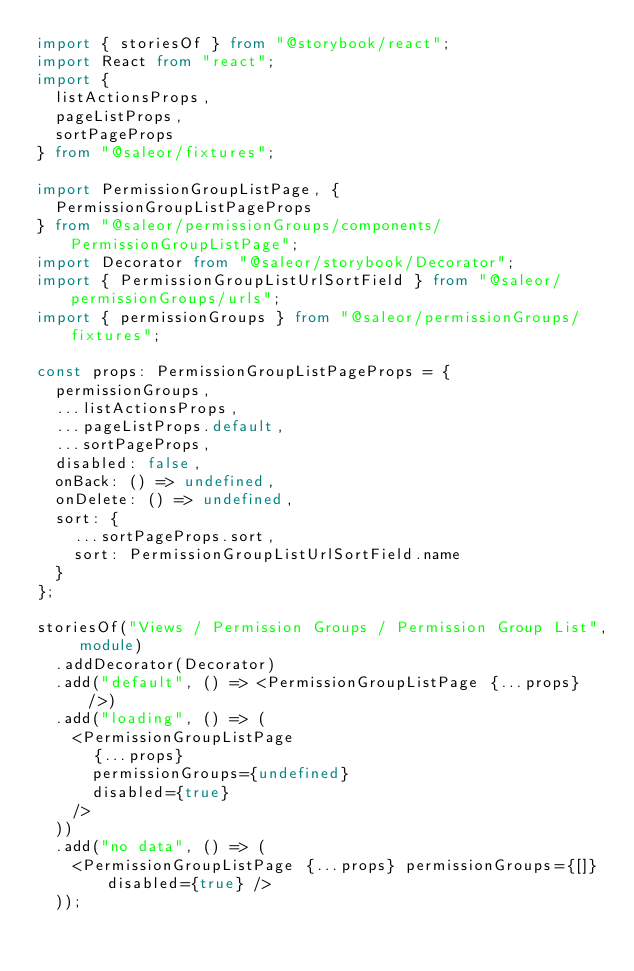<code> <loc_0><loc_0><loc_500><loc_500><_TypeScript_>import { storiesOf } from "@storybook/react";
import React from "react";
import {
  listActionsProps,
  pageListProps,
  sortPageProps
} from "@saleor/fixtures";

import PermissionGroupListPage, {
  PermissionGroupListPageProps
} from "@saleor/permissionGroups/components/PermissionGroupListPage";
import Decorator from "@saleor/storybook/Decorator";
import { PermissionGroupListUrlSortField } from "@saleor/permissionGroups/urls";
import { permissionGroups } from "@saleor/permissionGroups/fixtures";

const props: PermissionGroupListPageProps = {
  permissionGroups,
  ...listActionsProps,
  ...pageListProps.default,
  ...sortPageProps,
  disabled: false,
  onBack: () => undefined,
  onDelete: () => undefined,
  sort: {
    ...sortPageProps.sort,
    sort: PermissionGroupListUrlSortField.name
  }
};

storiesOf("Views / Permission Groups / Permission Group List", module)
  .addDecorator(Decorator)
  .add("default", () => <PermissionGroupListPage {...props} />)
  .add("loading", () => (
    <PermissionGroupListPage
      {...props}
      permissionGroups={undefined}
      disabled={true}
    />
  ))
  .add("no data", () => (
    <PermissionGroupListPage {...props} permissionGroups={[]} disabled={true} />
  ));
</code> 